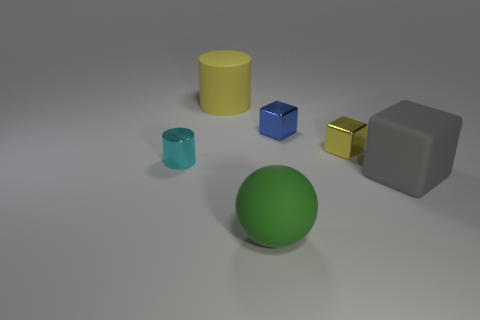What is the size of the metallic block that is the same color as the big cylinder?
Offer a terse response. Small. Do the big yellow matte object and the metal thing that is to the left of the large yellow matte object have the same shape?
Your answer should be compact. Yes. There is a cylinder that is left of the large rubber object that is behind the tiny metal thing on the left side of the big yellow thing; what is its material?
Ensure brevity in your answer.  Metal. What number of small cylinders are there?
Ensure brevity in your answer.  1. What number of yellow things are either tiny metal blocks or large balls?
Provide a short and direct response. 1. How many other things are there of the same shape as the gray object?
Your answer should be very brief. 2. There is a rubber thing that is behind the metal cylinder; does it have the same color as the small block in front of the blue shiny cube?
Your answer should be compact. Yes. How many tiny things are either cylinders or blue things?
Provide a succinct answer. 2. What is the size of the yellow rubber thing that is the same shape as the tiny cyan metallic thing?
Offer a very short reply. Large. What material is the big thing right of the matte ball that is to the right of the cyan cylinder made of?
Give a very brief answer. Rubber. 